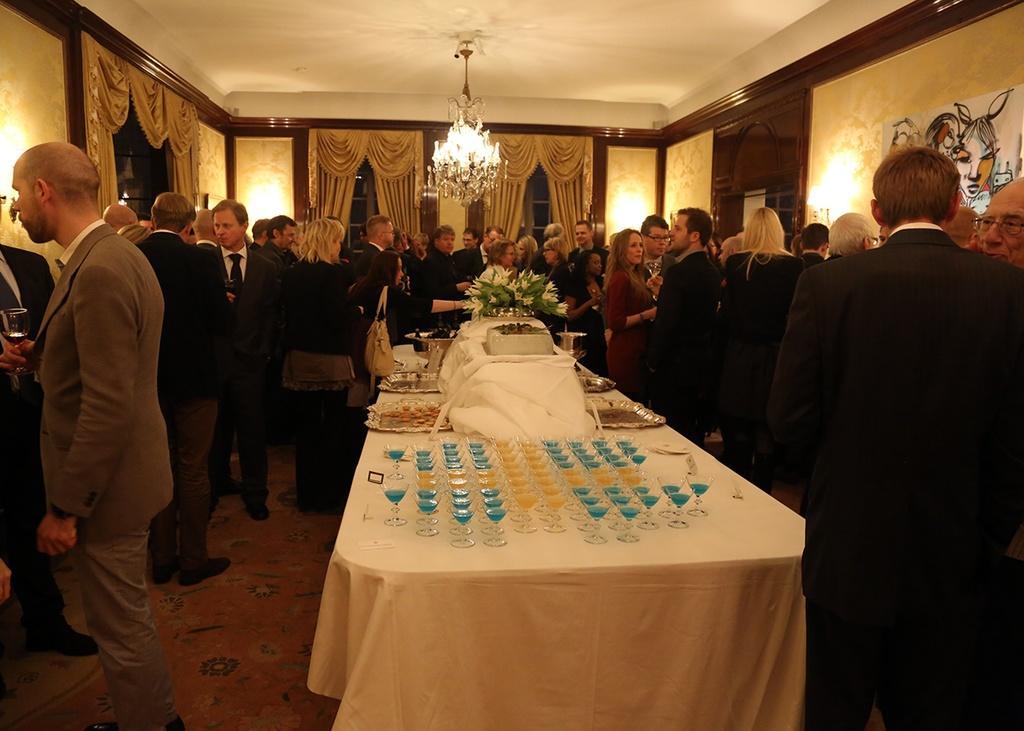Please provide a concise description of this image. This picture shows a group of people standing and few holding glasses in their hands and we see glasses and some food and flowers on the table and we see a chandelier light hanging 